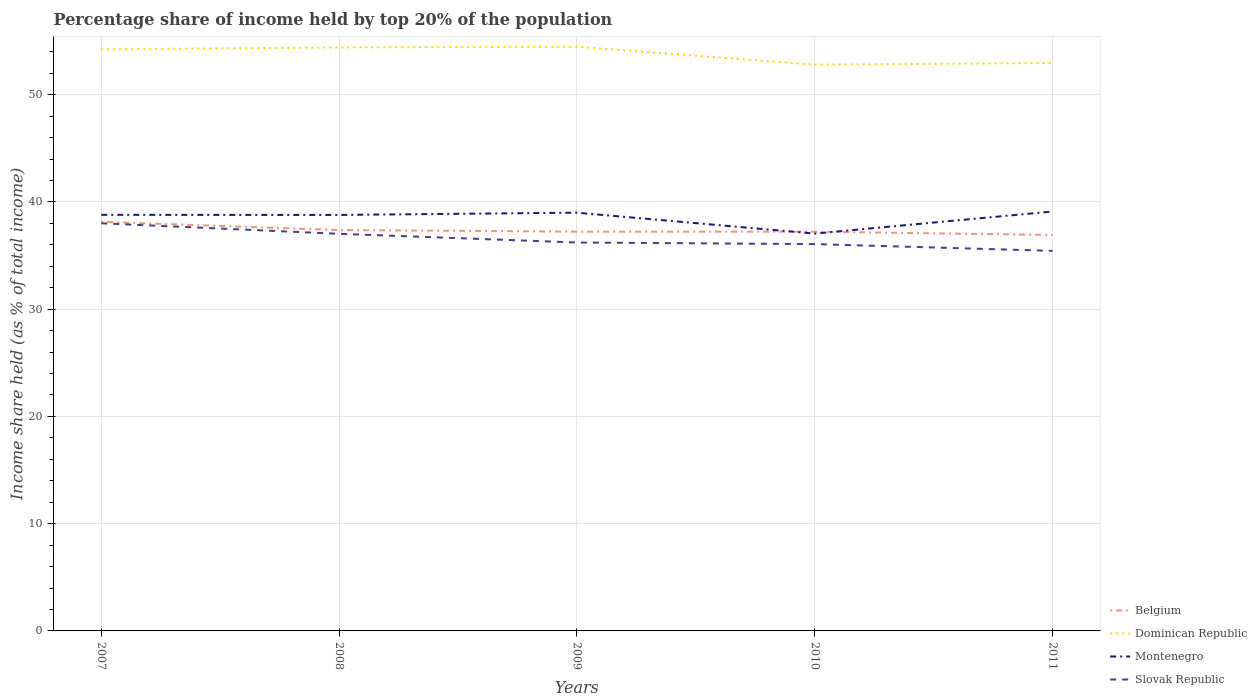Does the line corresponding to Montenegro intersect with the line corresponding to Dominican Republic?
Offer a very short reply. No. Is the number of lines equal to the number of legend labels?
Provide a succinct answer. Yes. Across all years, what is the maximum percentage share of income held by top 20% of the population in Dominican Republic?
Offer a terse response. 52.8. In which year was the percentage share of income held by top 20% of the population in Dominican Republic maximum?
Provide a short and direct response. 2010. What is the total percentage share of income held by top 20% of the population in Dominican Republic in the graph?
Your answer should be compact. 1.51. What is the difference between the highest and the second highest percentage share of income held by top 20% of the population in Slovak Republic?
Offer a very short reply. 2.57. Is the percentage share of income held by top 20% of the population in Montenegro strictly greater than the percentage share of income held by top 20% of the population in Slovak Republic over the years?
Make the answer very short. No. How many lines are there?
Offer a terse response. 4. Does the graph contain any zero values?
Provide a succinct answer. No. What is the title of the graph?
Keep it short and to the point. Percentage share of income held by top 20% of the population. What is the label or title of the Y-axis?
Provide a succinct answer. Income share held (as % of total income). What is the Income share held (as % of total income) in Belgium in 2007?
Ensure brevity in your answer.  38.15. What is the Income share held (as % of total income) of Dominican Republic in 2007?
Give a very brief answer. 54.23. What is the Income share held (as % of total income) of Montenegro in 2007?
Ensure brevity in your answer.  38.8. What is the Income share held (as % of total income) of Slovak Republic in 2007?
Keep it short and to the point. 38.01. What is the Income share held (as % of total income) of Belgium in 2008?
Your response must be concise. 37.38. What is the Income share held (as % of total income) in Dominican Republic in 2008?
Your answer should be very brief. 54.41. What is the Income share held (as % of total income) in Montenegro in 2008?
Provide a succinct answer. 38.79. What is the Income share held (as % of total income) of Slovak Republic in 2008?
Ensure brevity in your answer.  37.03. What is the Income share held (as % of total income) of Belgium in 2009?
Make the answer very short. 37.23. What is the Income share held (as % of total income) of Dominican Republic in 2009?
Your response must be concise. 54.47. What is the Income share held (as % of total income) of Slovak Republic in 2009?
Your response must be concise. 36.22. What is the Income share held (as % of total income) of Belgium in 2010?
Your answer should be very brief. 37.23. What is the Income share held (as % of total income) of Dominican Republic in 2010?
Your response must be concise. 52.8. What is the Income share held (as % of total income) of Montenegro in 2010?
Offer a very short reply. 37.05. What is the Income share held (as % of total income) of Slovak Republic in 2010?
Ensure brevity in your answer.  36.07. What is the Income share held (as % of total income) in Belgium in 2011?
Offer a terse response. 36.92. What is the Income share held (as % of total income) of Dominican Republic in 2011?
Provide a succinct answer. 52.96. What is the Income share held (as % of total income) of Montenegro in 2011?
Your answer should be compact. 39.11. What is the Income share held (as % of total income) in Slovak Republic in 2011?
Make the answer very short. 35.44. Across all years, what is the maximum Income share held (as % of total income) of Belgium?
Offer a very short reply. 38.15. Across all years, what is the maximum Income share held (as % of total income) in Dominican Republic?
Provide a succinct answer. 54.47. Across all years, what is the maximum Income share held (as % of total income) in Montenegro?
Make the answer very short. 39.11. Across all years, what is the maximum Income share held (as % of total income) of Slovak Republic?
Offer a very short reply. 38.01. Across all years, what is the minimum Income share held (as % of total income) of Belgium?
Make the answer very short. 36.92. Across all years, what is the minimum Income share held (as % of total income) of Dominican Republic?
Your answer should be very brief. 52.8. Across all years, what is the minimum Income share held (as % of total income) of Montenegro?
Offer a very short reply. 37.05. Across all years, what is the minimum Income share held (as % of total income) of Slovak Republic?
Ensure brevity in your answer.  35.44. What is the total Income share held (as % of total income) in Belgium in the graph?
Keep it short and to the point. 186.91. What is the total Income share held (as % of total income) in Dominican Republic in the graph?
Your answer should be compact. 268.87. What is the total Income share held (as % of total income) in Montenegro in the graph?
Offer a terse response. 192.75. What is the total Income share held (as % of total income) in Slovak Republic in the graph?
Offer a very short reply. 182.77. What is the difference between the Income share held (as % of total income) of Belgium in 2007 and that in 2008?
Offer a very short reply. 0.77. What is the difference between the Income share held (as % of total income) in Dominican Republic in 2007 and that in 2008?
Offer a terse response. -0.18. What is the difference between the Income share held (as % of total income) in Montenegro in 2007 and that in 2008?
Ensure brevity in your answer.  0.01. What is the difference between the Income share held (as % of total income) of Belgium in 2007 and that in 2009?
Provide a short and direct response. 0.92. What is the difference between the Income share held (as % of total income) in Dominican Republic in 2007 and that in 2009?
Offer a terse response. -0.24. What is the difference between the Income share held (as % of total income) of Montenegro in 2007 and that in 2009?
Your response must be concise. -0.2. What is the difference between the Income share held (as % of total income) in Slovak Republic in 2007 and that in 2009?
Make the answer very short. 1.79. What is the difference between the Income share held (as % of total income) in Belgium in 2007 and that in 2010?
Give a very brief answer. 0.92. What is the difference between the Income share held (as % of total income) of Dominican Republic in 2007 and that in 2010?
Give a very brief answer. 1.43. What is the difference between the Income share held (as % of total income) of Montenegro in 2007 and that in 2010?
Your answer should be very brief. 1.75. What is the difference between the Income share held (as % of total income) in Slovak Republic in 2007 and that in 2010?
Ensure brevity in your answer.  1.94. What is the difference between the Income share held (as % of total income) in Belgium in 2007 and that in 2011?
Provide a short and direct response. 1.23. What is the difference between the Income share held (as % of total income) in Dominican Republic in 2007 and that in 2011?
Ensure brevity in your answer.  1.27. What is the difference between the Income share held (as % of total income) in Montenegro in 2007 and that in 2011?
Your answer should be very brief. -0.31. What is the difference between the Income share held (as % of total income) in Slovak Republic in 2007 and that in 2011?
Provide a succinct answer. 2.57. What is the difference between the Income share held (as % of total income) of Belgium in 2008 and that in 2009?
Ensure brevity in your answer.  0.15. What is the difference between the Income share held (as % of total income) in Dominican Republic in 2008 and that in 2009?
Your answer should be very brief. -0.06. What is the difference between the Income share held (as % of total income) of Montenegro in 2008 and that in 2009?
Give a very brief answer. -0.21. What is the difference between the Income share held (as % of total income) in Slovak Republic in 2008 and that in 2009?
Your response must be concise. 0.81. What is the difference between the Income share held (as % of total income) of Dominican Republic in 2008 and that in 2010?
Give a very brief answer. 1.61. What is the difference between the Income share held (as % of total income) in Montenegro in 2008 and that in 2010?
Offer a very short reply. 1.74. What is the difference between the Income share held (as % of total income) in Belgium in 2008 and that in 2011?
Give a very brief answer. 0.46. What is the difference between the Income share held (as % of total income) of Dominican Republic in 2008 and that in 2011?
Offer a very short reply. 1.45. What is the difference between the Income share held (as % of total income) in Montenegro in 2008 and that in 2011?
Keep it short and to the point. -0.32. What is the difference between the Income share held (as % of total income) in Slovak Republic in 2008 and that in 2011?
Ensure brevity in your answer.  1.59. What is the difference between the Income share held (as % of total income) in Belgium in 2009 and that in 2010?
Your response must be concise. 0. What is the difference between the Income share held (as % of total income) in Dominican Republic in 2009 and that in 2010?
Your answer should be compact. 1.67. What is the difference between the Income share held (as % of total income) of Montenegro in 2009 and that in 2010?
Give a very brief answer. 1.95. What is the difference between the Income share held (as % of total income) of Belgium in 2009 and that in 2011?
Offer a terse response. 0.31. What is the difference between the Income share held (as % of total income) in Dominican Republic in 2009 and that in 2011?
Give a very brief answer. 1.51. What is the difference between the Income share held (as % of total income) in Montenegro in 2009 and that in 2011?
Your response must be concise. -0.11. What is the difference between the Income share held (as % of total income) in Slovak Republic in 2009 and that in 2011?
Your answer should be very brief. 0.78. What is the difference between the Income share held (as % of total income) in Belgium in 2010 and that in 2011?
Give a very brief answer. 0.31. What is the difference between the Income share held (as % of total income) of Dominican Republic in 2010 and that in 2011?
Ensure brevity in your answer.  -0.16. What is the difference between the Income share held (as % of total income) of Montenegro in 2010 and that in 2011?
Offer a terse response. -2.06. What is the difference between the Income share held (as % of total income) of Slovak Republic in 2010 and that in 2011?
Provide a succinct answer. 0.63. What is the difference between the Income share held (as % of total income) in Belgium in 2007 and the Income share held (as % of total income) in Dominican Republic in 2008?
Offer a very short reply. -16.26. What is the difference between the Income share held (as % of total income) of Belgium in 2007 and the Income share held (as % of total income) of Montenegro in 2008?
Ensure brevity in your answer.  -0.64. What is the difference between the Income share held (as % of total income) of Belgium in 2007 and the Income share held (as % of total income) of Slovak Republic in 2008?
Your response must be concise. 1.12. What is the difference between the Income share held (as % of total income) of Dominican Republic in 2007 and the Income share held (as % of total income) of Montenegro in 2008?
Offer a very short reply. 15.44. What is the difference between the Income share held (as % of total income) of Montenegro in 2007 and the Income share held (as % of total income) of Slovak Republic in 2008?
Offer a very short reply. 1.77. What is the difference between the Income share held (as % of total income) of Belgium in 2007 and the Income share held (as % of total income) of Dominican Republic in 2009?
Your response must be concise. -16.32. What is the difference between the Income share held (as % of total income) in Belgium in 2007 and the Income share held (as % of total income) in Montenegro in 2009?
Provide a short and direct response. -0.85. What is the difference between the Income share held (as % of total income) in Belgium in 2007 and the Income share held (as % of total income) in Slovak Republic in 2009?
Give a very brief answer. 1.93. What is the difference between the Income share held (as % of total income) in Dominican Republic in 2007 and the Income share held (as % of total income) in Montenegro in 2009?
Offer a very short reply. 15.23. What is the difference between the Income share held (as % of total income) of Dominican Republic in 2007 and the Income share held (as % of total income) of Slovak Republic in 2009?
Give a very brief answer. 18.01. What is the difference between the Income share held (as % of total income) of Montenegro in 2007 and the Income share held (as % of total income) of Slovak Republic in 2009?
Your response must be concise. 2.58. What is the difference between the Income share held (as % of total income) in Belgium in 2007 and the Income share held (as % of total income) in Dominican Republic in 2010?
Your answer should be very brief. -14.65. What is the difference between the Income share held (as % of total income) in Belgium in 2007 and the Income share held (as % of total income) in Montenegro in 2010?
Keep it short and to the point. 1.1. What is the difference between the Income share held (as % of total income) of Belgium in 2007 and the Income share held (as % of total income) of Slovak Republic in 2010?
Your response must be concise. 2.08. What is the difference between the Income share held (as % of total income) in Dominican Republic in 2007 and the Income share held (as % of total income) in Montenegro in 2010?
Offer a terse response. 17.18. What is the difference between the Income share held (as % of total income) of Dominican Republic in 2007 and the Income share held (as % of total income) of Slovak Republic in 2010?
Your answer should be compact. 18.16. What is the difference between the Income share held (as % of total income) in Montenegro in 2007 and the Income share held (as % of total income) in Slovak Republic in 2010?
Your answer should be very brief. 2.73. What is the difference between the Income share held (as % of total income) of Belgium in 2007 and the Income share held (as % of total income) of Dominican Republic in 2011?
Keep it short and to the point. -14.81. What is the difference between the Income share held (as % of total income) in Belgium in 2007 and the Income share held (as % of total income) in Montenegro in 2011?
Give a very brief answer. -0.96. What is the difference between the Income share held (as % of total income) of Belgium in 2007 and the Income share held (as % of total income) of Slovak Republic in 2011?
Your response must be concise. 2.71. What is the difference between the Income share held (as % of total income) in Dominican Republic in 2007 and the Income share held (as % of total income) in Montenegro in 2011?
Ensure brevity in your answer.  15.12. What is the difference between the Income share held (as % of total income) in Dominican Republic in 2007 and the Income share held (as % of total income) in Slovak Republic in 2011?
Keep it short and to the point. 18.79. What is the difference between the Income share held (as % of total income) of Montenegro in 2007 and the Income share held (as % of total income) of Slovak Republic in 2011?
Offer a very short reply. 3.36. What is the difference between the Income share held (as % of total income) of Belgium in 2008 and the Income share held (as % of total income) of Dominican Republic in 2009?
Your answer should be compact. -17.09. What is the difference between the Income share held (as % of total income) in Belgium in 2008 and the Income share held (as % of total income) in Montenegro in 2009?
Make the answer very short. -1.62. What is the difference between the Income share held (as % of total income) of Belgium in 2008 and the Income share held (as % of total income) of Slovak Republic in 2009?
Your answer should be compact. 1.16. What is the difference between the Income share held (as % of total income) of Dominican Republic in 2008 and the Income share held (as % of total income) of Montenegro in 2009?
Ensure brevity in your answer.  15.41. What is the difference between the Income share held (as % of total income) in Dominican Republic in 2008 and the Income share held (as % of total income) in Slovak Republic in 2009?
Offer a very short reply. 18.19. What is the difference between the Income share held (as % of total income) in Montenegro in 2008 and the Income share held (as % of total income) in Slovak Republic in 2009?
Offer a very short reply. 2.57. What is the difference between the Income share held (as % of total income) in Belgium in 2008 and the Income share held (as % of total income) in Dominican Republic in 2010?
Offer a terse response. -15.42. What is the difference between the Income share held (as % of total income) of Belgium in 2008 and the Income share held (as % of total income) of Montenegro in 2010?
Provide a short and direct response. 0.33. What is the difference between the Income share held (as % of total income) in Belgium in 2008 and the Income share held (as % of total income) in Slovak Republic in 2010?
Your response must be concise. 1.31. What is the difference between the Income share held (as % of total income) in Dominican Republic in 2008 and the Income share held (as % of total income) in Montenegro in 2010?
Keep it short and to the point. 17.36. What is the difference between the Income share held (as % of total income) in Dominican Republic in 2008 and the Income share held (as % of total income) in Slovak Republic in 2010?
Give a very brief answer. 18.34. What is the difference between the Income share held (as % of total income) of Montenegro in 2008 and the Income share held (as % of total income) of Slovak Republic in 2010?
Your answer should be compact. 2.72. What is the difference between the Income share held (as % of total income) in Belgium in 2008 and the Income share held (as % of total income) in Dominican Republic in 2011?
Your answer should be very brief. -15.58. What is the difference between the Income share held (as % of total income) in Belgium in 2008 and the Income share held (as % of total income) in Montenegro in 2011?
Provide a succinct answer. -1.73. What is the difference between the Income share held (as % of total income) of Belgium in 2008 and the Income share held (as % of total income) of Slovak Republic in 2011?
Make the answer very short. 1.94. What is the difference between the Income share held (as % of total income) in Dominican Republic in 2008 and the Income share held (as % of total income) in Slovak Republic in 2011?
Make the answer very short. 18.97. What is the difference between the Income share held (as % of total income) in Montenegro in 2008 and the Income share held (as % of total income) in Slovak Republic in 2011?
Ensure brevity in your answer.  3.35. What is the difference between the Income share held (as % of total income) of Belgium in 2009 and the Income share held (as % of total income) of Dominican Republic in 2010?
Ensure brevity in your answer.  -15.57. What is the difference between the Income share held (as % of total income) of Belgium in 2009 and the Income share held (as % of total income) of Montenegro in 2010?
Your answer should be very brief. 0.18. What is the difference between the Income share held (as % of total income) of Belgium in 2009 and the Income share held (as % of total income) of Slovak Republic in 2010?
Provide a short and direct response. 1.16. What is the difference between the Income share held (as % of total income) of Dominican Republic in 2009 and the Income share held (as % of total income) of Montenegro in 2010?
Your response must be concise. 17.42. What is the difference between the Income share held (as % of total income) in Dominican Republic in 2009 and the Income share held (as % of total income) in Slovak Republic in 2010?
Offer a very short reply. 18.4. What is the difference between the Income share held (as % of total income) in Montenegro in 2009 and the Income share held (as % of total income) in Slovak Republic in 2010?
Ensure brevity in your answer.  2.93. What is the difference between the Income share held (as % of total income) in Belgium in 2009 and the Income share held (as % of total income) in Dominican Republic in 2011?
Keep it short and to the point. -15.73. What is the difference between the Income share held (as % of total income) of Belgium in 2009 and the Income share held (as % of total income) of Montenegro in 2011?
Make the answer very short. -1.88. What is the difference between the Income share held (as % of total income) in Belgium in 2009 and the Income share held (as % of total income) in Slovak Republic in 2011?
Provide a succinct answer. 1.79. What is the difference between the Income share held (as % of total income) in Dominican Republic in 2009 and the Income share held (as % of total income) in Montenegro in 2011?
Make the answer very short. 15.36. What is the difference between the Income share held (as % of total income) in Dominican Republic in 2009 and the Income share held (as % of total income) in Slovak Republic in 2011?
Your answer should be very brief. 19.03. What is the difference between the Income share held (as % of total income) of Montenegro in 2009 and the Income share held (as % of total income) of Slovak Republic in 2011?
Keep it short and to the point. 3.56. What is the difference between the Income share held (as % of total income) of Belgium in 2010 and the Income share held (as % of total income) of Dominican Republic in 2011?
Provide a short and direct response. -15.73. What is the difference between the Income share held (as % of total income) in Belgium in 2010 and the Income share held (as % of total income) in Montenegro in 2011?
Your answer should be very brief. -1.88. What is the difference between the Income share held (as % of total income) in Belgium in 2010 and the Income share held (as % of total income) in Slovak Republic in 2011?
Offer a very short reply. 1.79. What is the difference between the Income share held (as % of total income) in Dominican Republic in 2010 and the Income share held (as % of total income) in Montenegro in 2011?
Make the answer very short. 13.69. What is the difference between the Income share held (as % of total income) in Dominican Republic in 2010 and the Income share held (as % of total income) in Slovak Republic in 2011?
Your answer should be very brief. 17.36. What is the difference between the Income share held (as % of total income) of Montenegro in 2010 and the Income share held (as % of total income) of Slovak Republic in 2011?
Your answer should be compact. 1.61. What is the average Income share held (as % of total income) of Belgium per year?
Ensure brevity in your answer.  37.38. What is the average Income share held (as % of total income) of Dominican Republic per year?
Provide a short and direct response. 53.77. What is the average Income share held (as % of total income) in Montenegro per year?
Offer a terse response. 38.55. What is the average Income share held (as % of total income) in Slovak Republic per year?
Give a very brief answer. 36.55. In the year 2007, what is the difference between the Income share held (as % of total income) of Belgium and Income share held (as % of total income) of Dominican Republic?
Your answer should be very brief. -16.08. In the year 2007, what is the difference between the Income share held (as % of total income) in Belgium and Income share held (as % of total income) in Montenegro?
Offer a very short reply. -0.65. In the year 2007, what is the difference between the Income share held (as % of total income) of Belgium and Income share held (as % of total income) of Slovak Republic?
Offer a terse response. 0.14. In the year 2007, what is the difference between the Income share held (as % of total income) of Dominican Republic and Income share held (as % of total income) of Montenegro?
Provide a short and direct response. 15.43. In the year 2007, what is the difference between the Income share held (as % of total income) in Dominican Republic and Income share held (as % of total income) in Slovak Republic?
Give a very brief answer. 16.22. In the year 2007, what is the difference between the Income share held (as % of total income) in Montenegro and Income share held (as % of total income) in Slovak Republic?
Make the answer very short. 0.79. In the year 2008, what is the difference between the Income share held (as % of total income) of Belgium and Income share held (as % of total income) of Dominican Republic?
Make the answer very short. -17.03. In the year 2008, what is the difference between the Income share held (as % of total income) of Belgium and Income share held (as % of total income) of Montenegro?
Keep it short and to the point. -1.41. In the year 2008, what is the difference between the Income share held (as % of total income) of Belgium and Income share held (as % of total income) of Slovak Republic?
Give a very brief answer. 0.35. In the year 2008, what is the difference between the Income share held (as % of total income) in Dominican Republic and Income share held (as % of total income) in Montenegro?
Make the answer very short. 15.62. In the year 2008, what is the difference between the Income share held (as % of total income) of Dominican Republic and Income share held (as % of total income) of Slovak Republic?
Provide a short and direct response. 17.38. In the year 2008, what is the difference between the Income share held (as % of total income) of Montenegro and Income share held (as % of total income) of Slovak Republic?
Keep it short and to the point. 1.76. In the year 2009, what is the difference between the Income share held (as % of total income) in Belgium and Income share held (as % of total income) in Dominican Republic?
Keep it short and to the point. -17.24. In the year 2009, what is the difference between the Income share held (as % of total income) in Belgium and Income share held (as % of total income) in Montenegro?
Offer a terse response. -1.77. In the year 2009, what is the difference between the Income share held (as % of total income) of Belgium and Income share held (as % of total income) of Slovak Republic?
Your response must be concise. 1.01. In the year 2009, what is the difference between the Income share held (as % of total income) of Dominican Republic and Income share held (as % of total income) of Montenegro?
Offer a very short reply. 15.47. In the year 2009, what is the difference between the Income share held (as % of total income) in Dominican Republic and Income share held (as % of total income) in Slovak Republic?
Provide a succinct answer. 18.25. In the year 2009, what is the difference between the Income share held (as % of total income) of Montenegro and Income share held (as % of total income) of Slovak Republic?
Give a very brief answer. 2.78. In the year 2010, what is the difference between the Income share held (as % of total income) of Belgium and Income share held (as % of total income) of Dominican Republic?
Keep it short and to the point. -15.57. In the year 2010, what is the difference between the Income share held (as % of total income) in Belgium and Income share held (as % of total income) in Montenegro?
Offer a very short reply. 0.18. In the year 2010, what is the difference between the Income share held (as % of total income) of Belgium and Income share held (as % of total income) of Slovak Republic?
Provide a short and direct response. 1.16. In the year 2010, what is the difference between the Income share held (as % of total income) in Dominican Republic and Income share held (as % of total income) in Montenegro?
Your answer should be very brief. 15.75. In the year 2010, what is the difference between the Income share held (as % of total income) of Dominican Republic and Income share held (as % of total income) of Slovak Republic?
Give a very brief answer. 16.73. In the year 2010, what is the difference between the Income share held (as % of total income) in Montenegro and Income share held (as % of total income) in Slovak Republic?
Offer a terse response. 0.98. In the year 2011, what is the difference between the Income share held (as % of total income) in Belgium and Income share held (as % of total income) in Dominican Republic?
Provide a succinct answer. -16.04. In the year 2011, what is the difference between the Income share held (as % of total income) of Belgium and Income share held (as % of total income) of Montenegro?
Provide a succinct answer. -2.19. In the year 2011, what is the difference between the Income share held (as % of total income) in Belgium and Income share held (as % of total income) in Slovak Republic?
Your response must be concise. 1.48. In the year 2011, what is the difference between the Income share held (as % of total income) of Dominican Republic and Income share held (as % of total income) of Montenegro?
Your response must be concise. 13.85. In the year 2011, what is the difference between the Income share held (as % of total income) in Dominican Republic and Income share held (as % of total income) in Slovak Republic?
Keep it short and to the point. 17.52. In the year 2011, what is the difference between the Income share held (as % of total income) of Montenegro and Income share held (as % of total income) of Slovak Republic?
Ensure brevity in your answer.  3.67. What is the ratio of the Income share held (as % of total income) of Belgium in 2007 to that in 2008?
Make the answer very short. 1.02. What is the ratio of the Income share held (as % of total income) in Montenegro in 2007 to that in 2008?
Provide a short and direct response. 1. What is the ratio of the Income share held (as % of total income) in Slovak Republic in 2007 to that in 2008?
Provide a short and direct response. 1.03. What is the ratio of the Income share held (as % of total income) of Belgium in 2007 to that in 2009?
Offer a terse response. 1.02. What is the ratio of the Income share held (as % of total income) in Slovak Republic in 2007 to that in 2009?
Your answer should be compact. 1.05. What is the ratio of the Income share held (as % of total income) in Belgium in 2007 to that in 2010?
Provide a succinct answer. 1.02. What is the ratio of the Income share held (as % of total income) of Dominican Republic in 2007 to that in 2010?
Provide a succinct answer. 1.03. What is the ratio of the Income share held (as % of total income) of Montenegro in 2007 to that in 2010?
Provide a succinct answer. 1.05. What is the ratio of the Income share held (as % of total income) of Slovak Republic in 2007 to that in 2010?
Provide a succinct answer. 1.05. What is the ratio of the Income share held (as % of total income) of Belgium in 2007 to that in 2011?
Your answer should be very brief. 1.03. What is the ratio of the Income share held (as % of total income) in Montenegro in 2007 to that in 2011?
Provide a short and direct response. 0.99. What is the ratio of the Income share held (as % of total income) of Slovak Republic in 2007 to that in 2011?
Provide a short and direct response. 1.07. What is the ratio of the Income share held (as % of total income) in Montenegro in 2008 to that in 2009?
Give a very brief answer. 0.99. What is the ratio of the Income share held (as % of total income) in Slovak Republic in 2008 to that in 2009?
Offer a terse response. 1.02. What is the ratio of the Income share held (as % of total income) in Belgium in 2008 to that in 2010?
Your answer should be very brief. 1. What is the ratio of the Income share held (as % of total income) of Dominican Republic in 2008 to that in 2010?
Your answer should be very brief. 1.03. What is the ratio of the Income share held (as % of total income) in Montenegro in 2008 to that in 2010?
Ensure brevity in your answer.  1.05. What is the ratio of the Income share held (as % of total income) of Slovak Republic in 2008 to that in 2010?
Provide a succinct answer. 1.03. What is the ratio of the Income share held (as % of total income) of Belgium in 2008 to that in 2011?
Your answer should be very brief. 1.01. What is the ratio of the Income share held (as % of total income) of Dominican Republic in 2008 to that in 2011?
Provide a short and direct response. 1.03. What is the ratio of the Income share held (as % of total income) of Slovak Republic in 2008 to that in 2011?
Keep it short and to the point. 1.04. What is the ratio of the Income share held (as % of total income) in Dominican Republic in 2009 to that in 2010?
Ensure brevity in your answer.  1.03. What is the ratio of the Income share held (as % of total income) in Montenegro in 2009 to that in 2010?
Provide a succinct answer. 1.05. What is the ratio of the Income share held (as % of total income) in Slovak Republic in 2009 to that in 2010?
Ensure brevity in your answer.  1. What is the ratio of the Income share held (as % of total income) in Belgium in 2009 to that in 2011?
Your response must be concise. 1.01. What is the ratio of the Income share held (as % of total income) in Dominican Republic in 2009 to that in 2011?
Make the answer very short. 1.03. What is the ratio of the Income share held (as % of total income) in Slovak Republic in 2009 to that in 2011?
Provide a succinct answer. 1.02. What is the ratio of the Income share held (as % of total income) in Belgium in 2010 to that in 2011?
Your answer should be compact. 1.01. What is the ratio of the Income share held (as % of total income) in Dominican Republic in 2010 to that in 2011?
Ensure brevity in your answer.  1. What is the ratio of the Income share held (as % of total income) in Montenegro in 2010 to that in 2011?
Your answer should be very brief. 0.95. What is the ratio of the Income share held (as % of total income) in Slovak Republic in 2010 to that in 2011?
Ensure brevity in your answer.  1.02. What is the difference between the highest and the second highest Income share held (as % of total income) of Belgium?
Ensure brevity in your answer.  0.77. What is the difference between the highest and the second highest Income share held (as % of total income) in Dominican Republic?
Your answer should be compact. 0.06. What is the difference between the highest and the second highest Income share held (as % of total income) in Montenegro?
Ensure brevity in your answer.  0.11. What is the difference between the highest and the lowest Income share held (as % of total income) of Belgium?
Your response must be concise. 1.23. What is the difference between the highest and the lowest Income share held (as % of total income) of Dominican Republic?
Your answer should be very brief. 1.67. What is the difference between the highest and the lowest Income share held (as % of total income) in Montenegro?
Offer a terse response. 2.06. What is the difference between the highest and the lowest Income share held (as % of total income) of Slovak Republic?
Offer a terse response. 2.57. 